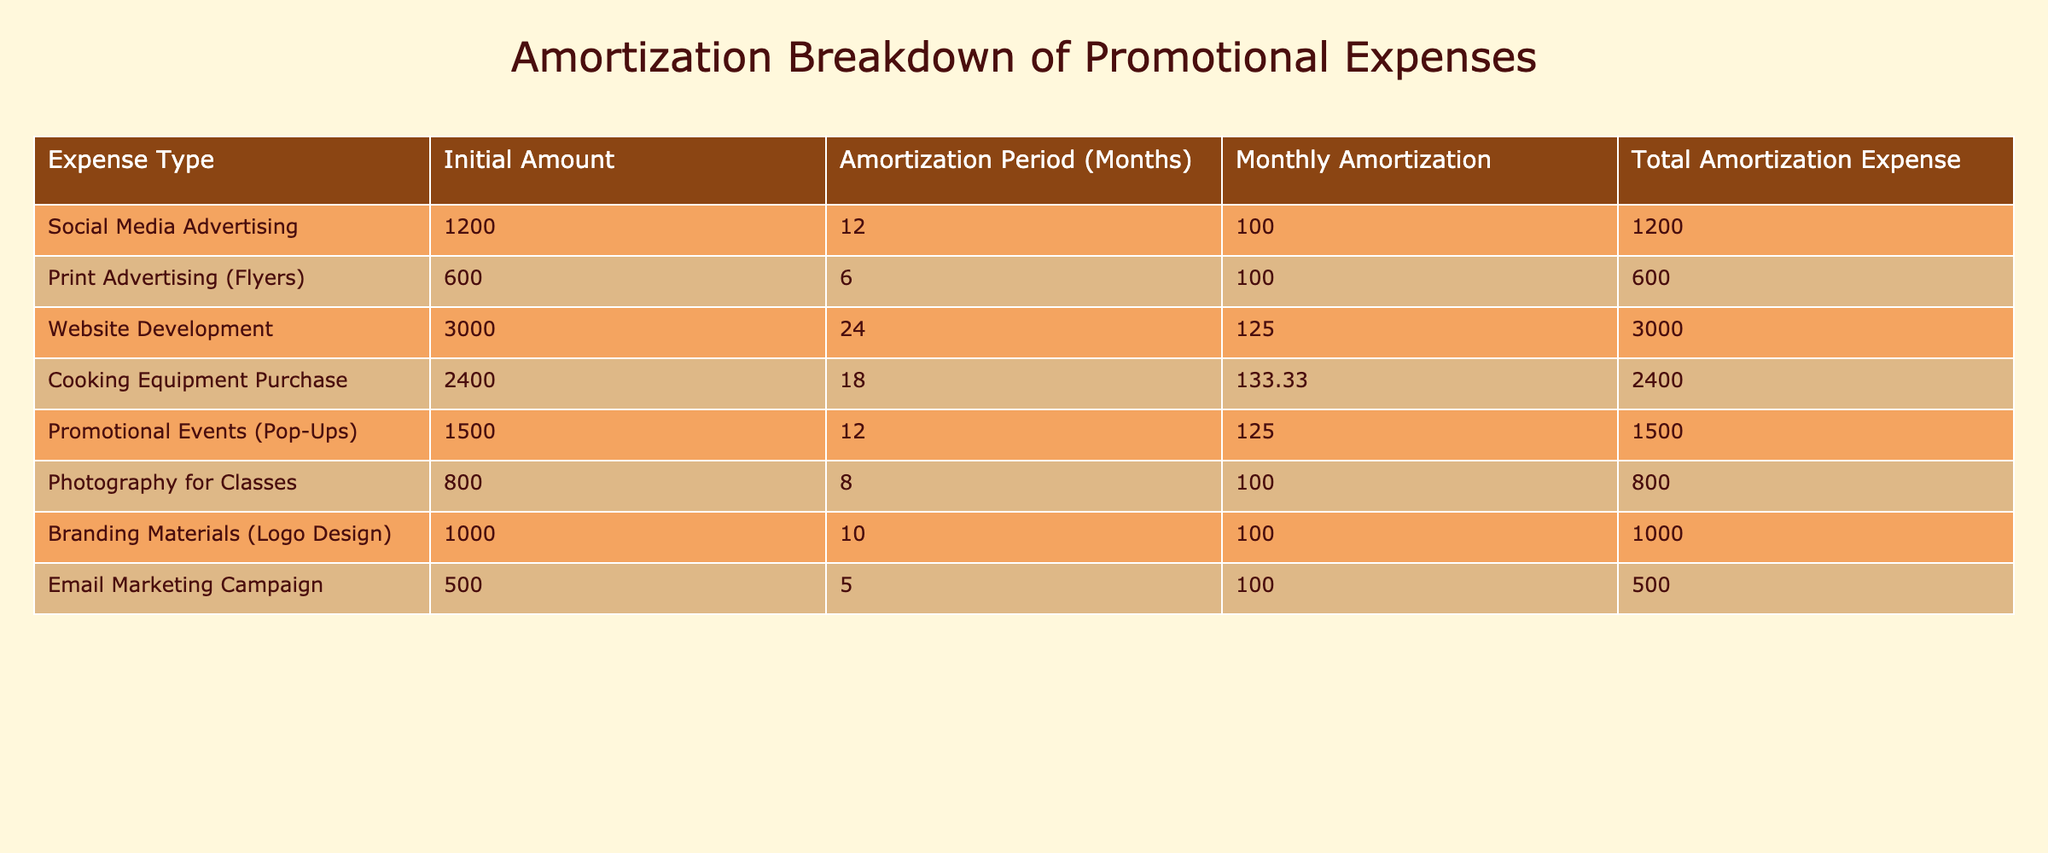What is the total amortization expense for Social Media Advertising? The table shows that the total amortization expense for Social Media Advertising is listed directly in its row, where it states 1200.
Answer: 1200 What is the monthly amortization for Website Development? Looking at the row for Website Development, the monthly amortization is explicitly marked as 125.
Answer: 125 How many months is the amortization period for Photography for Classes? In the row for Photography for Classes, the amortization period is clearly stated as 8 months.
Answer: 8 What is the average monthly amortization across all expense types? To find the average, we sum the monthly amortization values: (100 + 100 + 125 + 133.33 + 125 + 100 + 100 + 100) =  980.33. Then, we divide by the number of expense types (8), yielding 980.33/8 = 122.54.
Answer: 122.54 Are the total amortization expenses for Branding Materials greater than for Photography for Classes? We compare the total amortization expenses from each row: Branding Materials is 1000 and Photography for Classes is 800. Since 1000 is greater than 800, the statement is true.
Answer: Yes Which expense type has the longest amortization period? We look through the table to find the maximum value in the "Amortization Period" column. The maximum is 24 months for Website Development, confirming that it has the longest amortization period.
Answer: Website Development What is the total amortization expense for Pop-Ups and Cooking Equipment Purchase combined? We add the total amortization expenses for both expense types: Pop-Ups is 1500 and Cooking Equipment Purchase is 2400. Therefore, the combined total is 1500 + 2400 = 3900.
Answer: 3900 Is the monthly amortization for Print Advertising higher than that for Email Marketing Campaign? We observe the monthly amortization values in their respective rows: Print Advertising is 100 and Email Marketing Campaign is also 100. Since they are equal, the statement is false.
Answer: No How much more is the total amortization expense for Cooking Equipment Purchase compared to that for Email Marketing Campaign? Total amortization expense for Cooking Equipment is 2400 and for Email Marketing Campaign is 500. To find the difference, the calculation is 2400 - 500 = 1900.
Answer: 1900 